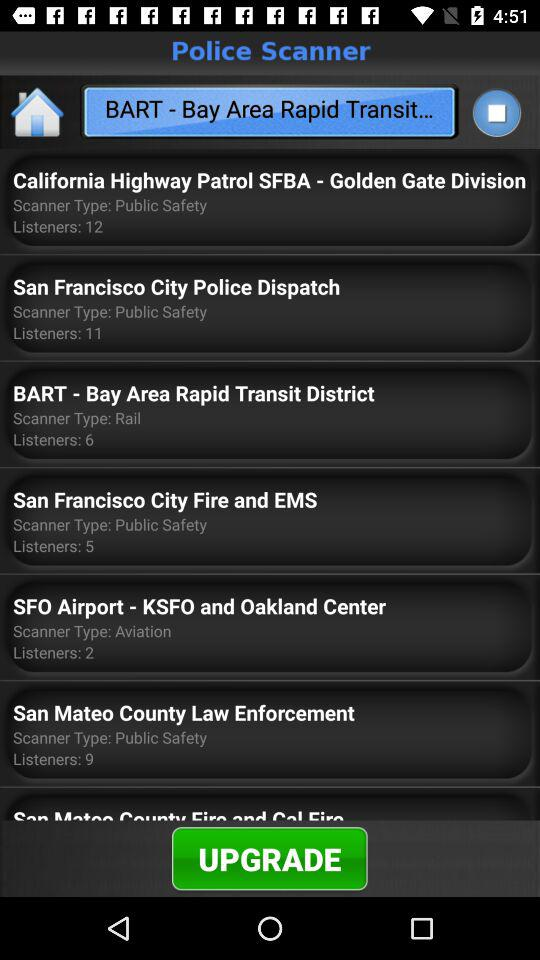What is the number of listeners of "San Mateo County Law Enforcement"? The number of listeners of "San Mateo County Law Enforcement" is 9. 